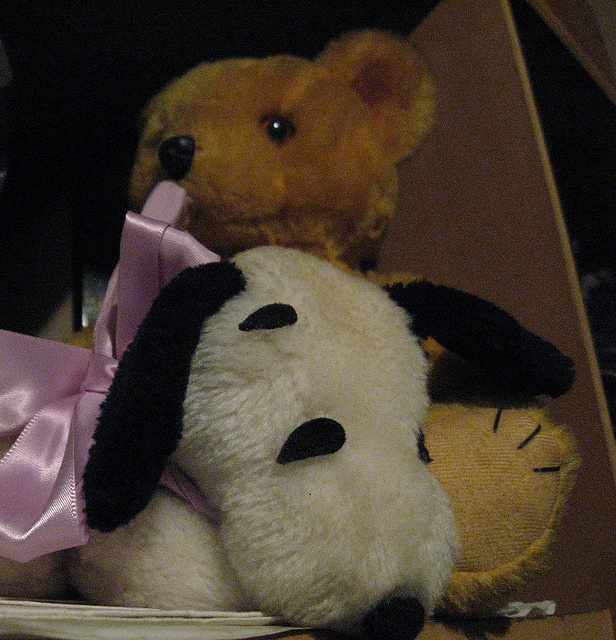Describe the objects in this image and their specific colors. I can see a teddy bear in black, gray, olive, and maroon tones in this image. 